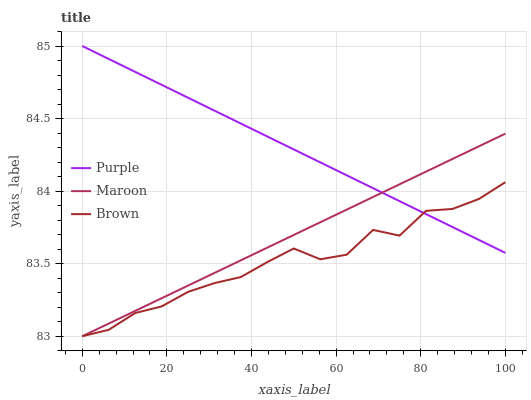Does Brown have the minimum area under the curve?
Answer yes or no. Yes. Does Purple have the maximum area under the curve?
Answer yes or no. Yes. Does Maroon have the minimum area under the curve?
Answer yes or no. No. Does Maroon have the maximum area under the curve?
Answer yes or no. No. Is Purple the smoothest?
Answer yes or no. Yes. Is Brown the roughest?
Answer yes or no. Yes. Is Brown the smoothest?
Answer yes or no. No. Is Maroon the roughest?
Answer yes or no. No. Does Brown have the lowest value?
Answer yes or no. Yes. Does Purple have the highest value?
Answer yes or no. Yes. Does Maroon have the highest value?
Answer yes or no. No. Does Maroon intersect Purple?
Answer yes or no. Yes. Is Maroon less than Purple?
Answer yes or no. No. Is Maroon greater than Purple?
Answer yes or no. No. 